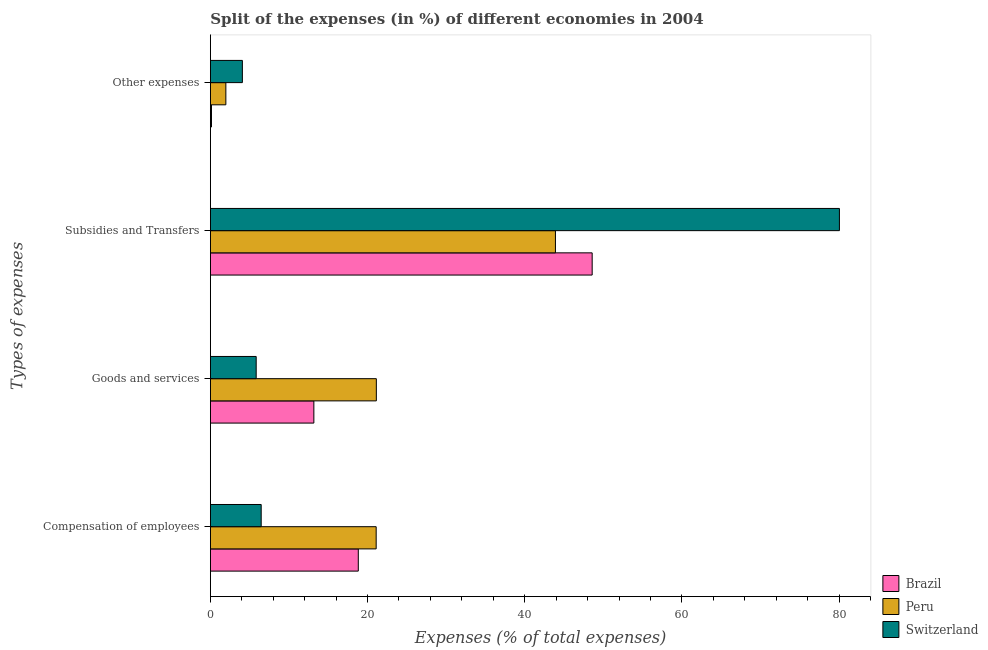How many different coloured bars are there?
Keep it short and to the point. 3. Are the number of bars on each tick of the Y-axis equal?
Give a very brief answer. Yes. How many bars are there on the 3rd tick from the top?
Ensure brevity in your answer.  3. How many bars are there on the 4th tick from the bottom?
Keep it short and to the point. 3. What is the label of the 4th group of bars from the top?
Provide a succinct answer. Compensation of employees. What is the percentage of amount spent on subsidies in Brazil?
Your response must be concise. 48.59. Across all countries, what is the maximum percentage of amount spent on subsidies?
Provide a short and direct response. 80.05. Across all countries, what is the minimum percentage of amount spent on goods and services?
Make the answer very short. 5.83. In which country was the percentage of amount spent on other expenses maximum?
Provide a succinct answer. Switzerland. In which country was the percentage of amount spent on compensation of employees minimum?
Provide a short and direct response. Switzerland. What is the total percentage of amount spent on goods and services in the graph?
Give a very brief answer. 40.11. What is the difference between the percentage of amount spent on other expenses in Peru and that in Switzerland?
Offer a very short reply. -2.1. What is the difference between the percentage of amount spent on compensation of employees in Brazil and the percentage of amount spent on goods and services in Switzerland?
Keep it short and to the point. 13. What is the average percentage of amount spent on subsidies per country?
Offer a terse response. 57.52. What is the difference between the percentage of amount spent on subsidies and percentage of amount spent on other expenses in Peru?
Provide a short and direct response. 41.94. In how many countries, is the percentage of amount spent on compensation of employees greater than 40 %?
Give a very brief answer. 0. What is the ratio of the percentage of amount spent on compensation of employees in Switzerland to that in Brazil?
Provide a succinct answer. 0.34. Is the percentage of amount spent on compensation of employees in Switzerland less than that in Peru?
Your response must be concise. Yes. Is the difference between the percentage of amount spent on other expenses in Brazil and Switzerland greater than the difference between the percentage of amount spent on compensation of employees in Brazil and Switzerland?
Give a very brief answer. No. What is the difference between the highest and the second highest percentage of amount spent on goods and services?
Make the answer very short. 7.95. What is the difference between the highest and the lowest percentage of amount spent on goods and services?
Ensure brevity in your answer.  15.29. In how many countries, is the percentage of amount spent on goods and services greater than the average percentage of amount spent on goods and services taken over all countries?
Provide a succinct answer. 1. What does the 3rd bar from the bottom in Subsidies and Transfers represents?
Offer a very short reply. Switzerland. How many bars are there?
Make the answer very short. 12. How many countries are there in the graph?
Your answer should be compact. 3. Where does the legend appear in the graph?
Provide a short and direct response. Bottom right. What is the title of the graph?
Offer a very short reply. Split of the expenses (in %) of different economies in 2004. What is the label or title of the X-axis?
Make the answer very short. Expenses (% of total expenses). What is the label or title of the Y-axis?
Give a very brief answer. Types of expenses. What is the Expenses (% of total expenses) in Brazil in Compensation of employees?
Keep it short and to the point. 18.82. What is the Expenses (% of total expenses) in Peru in Compensation of employees?
Provide a short and direct response. 21.1. What is the Expenses (% of total expenses) in Switzerland in Compensation of employees?
Provide a succinct answer. 6.47. What is the Expenses (% of total expenses) in Brazil in Goods and services?
Give a very brief answer. 13.17. What is the Expenses (% of total expenses) of Peru in Goods and services?
Offer a terse response. 21.12. What is the Expenses (% of total expenses) in Switzerland in Goods and services?
Give a very brief answer. 5.83. What is the Expenses (% of total expenses) of Brazil in Subsidies and Transfers?
Make the answer very short. 48.59. What is the Expenses (% of total expenses) in Peru in Subsidies and Transfers?
Your response must be concise. 43.91. What is the Expenses (% of total expenses) in Switzerland in Subsidies and Transfers?
Give a very brief answer. 80.05. What is the Expenses (% of total expenses) in Brazil in Other expenses?
Your response must be concise. 0.14. What is the Expenses (% of total expenses) in Peru in Other expenses?
Provide a short and direct response. 1.97. What is the Expenses (% of total expenses) in Switzerland in Other expenses?
Offer a very short reply. 4.07. Across all Types of expenses, what is the maximum Expenses (% of total expenses) in Brazil?
Your response must be concise. 48.59. Across all Types of expenses, what is the maximum Expenses (% of total expenses) of Peru?
Keep it short and to the point. 43.91. Across all Types of expenses, what is the maximum Expenses (% of total expenses) in Switzerland?
Your response must be concise. 80.05. Across all Types of expenses, what is the minimum Expenses (% of total expenses) in Brazil?
Offer a very short reply. 0.14. Across all Types of expenses, what is the minimum Expenses (% of total expenses) of Peru?
Provide a short and direct response. 1.97. Across all Types of expenses, what is the minimum Expenses (% of total expenses) of Switzerland?
Your answer should be compact. 4.07. What is the total Expenses (% of total expenses) of Brazil in the graph?
Offer a very short reply. 80.72. What is the total Expenses (% of total expenses) in Peru in the graph?
Offer a very short reply. 88.1. What is the total Expenses (% of total expenses) in Switzerland in the graph?
Keep it short and to the point. 96.41. What is the difference between the Expenses (% of total expenses) in Brazil in Compensation of employees and that in Goods and services?
Offer a very short reply. 5.66. What is the difference between the Expenses (% of total expenses) of Peru in Compensation of employees and that in Goods and services?
Provide a short and direct response. -0.02. What is the difference between the Expenses (% of total expenses) in Switzerland in Compensation of employees and that in Goods and services?
Provide a succinct answer. 0.64. What is the difference between the Expenses (% of total expenses) of Brazil in Compensation of employees and that in Subsidies and Transfers?
Provide a short and direct response. -29.76. What is the difference between the Expenses (% of total expenses) in Peru in Compensation of employees and that in Subsidies and Transfers?
Provide a succinct answer. -22.81. What is the difference between the Expenses (% of total expenses) in Switzerland in Compensation of employees and that in Subsidies and Transfers?
Provide a short and direct response. -73.58. What is the difference between the Expenses (% of total expenses) of Brazil in Compensation of employees and that in Other expenses?
Offer a terse response. 18.68. What is the difference between the Expenses (% of total expenses) of Peru in Compensation of employees and that in Other expenses?
Offer a very short reply. 19.13. What is the difference between the Expenses (% of total expenses) of Switzerland in Compensation of employees and that in Other expenses?
Your answer should be very brief. 2.39. What is the difference between the Expenses (% of total expenses) of Brazil in Goods and services and that in Subsidies and Transfers?
Your response must be concise. -35.42. What is the difference between the Expenses (% of total expenses) in Peru in Goods and services and that in Subsidies and Transfers?
Your answer should be compact. -22.79. What is the difference between the Expenses (% of total expenses) of Switzerland in Goods and services and that in Subsidies and Transfers?
Give a very brief answer. -74.22. What is the difference between the Expenses (% of total expenses) in Brazil in Goods and services and that in Other expenses?
Provide a succinct answer. 13.03. What is the difference between the Expenses (% of total expenses) of Peru in Goods and services and that in Other expenses?
Keep it short and to the point. 19.15. What is the difference between the Expenses (% of total expenses) of Switzerland in Goods and services and that in Other expenses?
Provide a succinct answer. 1.76. What is the difference between the Expenses (% of total expenses) in Brazil in Subsidies and Transfers and that in Other expenses?
Your answer should be very brief. 48.45. What is the difference between the Expenses (% of total expenses) in Peru in Subsidies and Transfers and that in Other expenses?
Provide a short and direct response. 41.94. What is the difference between the Expenses (% of total expenses) of Switzerland in Subsidies and Transfers and that in Other expenses?
Provide a short and direct response. 75.98. What is the difference between the Expenses (% of total expenses) in Brazil in Compensation of employees and the Expenses (% of total expenses) in Peru in Goods and services?
Keep it short and to the point. -2.3. What is the difference between the Expenses (% of total expenses) of Brazil in Compensation of employees and the Expenses (% of total expenses) of Switzerland in Goods and services?
Provide a succinct answer. 13. What is the difference between the Expenses (% of total expenses) in Peru in Compensation of employees and the Expenses (% of total expenses) in Switzerland in Goods and services?
Offer a very short reply. 15.27. What is the difference between the Expenses (% of total expenses) in Brazil in Compensation of employees and the Expenses (% of total expenses) in Peru in Subsidies and Transfers?
Give a very brief answer. -25.09. What is the difference between the Expenses (% of total expenses) of Brazil in Compensation of employees and the Expenses (% of total expenses) of Switzerland in Subsidies and Transfers?
Your answer should be very brief. -61.23. What is the difference between the Expenses (% of total expenses) of Peru in Compensation of employees and the Expenses (% of total expenses) of Switzerland in Subsidies and Transfers?
Offer a terse response. -58.95. What is the difference between the Expenses (% of total expenses) in Brazil in Compensation of employees and the Expenses (% of total expenses) in Peru in Other expenses?
Give a very brief answer. 16.85. What is the difference between the Expenses (% of total expenses) in Brazil in Compensation of employees and the Expenses (% of total expenses) in Switzerland in Other expenses?
Offer a terse response. 14.75. What is the difference between the Expenses (% of total expenses) in Peru in Compensation of employees and the Expenses (% of total expenses) in Switzerland in Other expenses?
Offer a very short reply. 17.03. What is the difference between the Expenses (% of total expenses) of Brazil in Goods and services and the Expenses (% of total expenses) of Peru in Subsidies and Transfers?
Your answer should be very brief. -30.74. What is the difference between the Expenses (% of total expenses) of Brazil in Goods and services and the Expenses (% of total expenses) of Switzerland in Subsidies and Transfers?
Offer a very short reply. -66.88. What is the difference between the Expenses (% of total expenses) in Peru in Goods and services and the Expenses (% of total expenses) in Switzerland in Subsidies and Transfers?
Keep it short and to the point. -58.93. What is the difference between the Expenses (% of total expenses) of Brazil in Goods and services and the Expenses (% of total expenses) of Peru in Other expenses?
Give a very brief answer. 11.2. What is the difference between the Expenses (% of total expenses) of Brazil in Goods and services and the Expenses (% of total expenses) of Switzerland in Other expenses?
Provide a short and direct response. 9.1. What is the difference between the Expenses (% of total expenses) in Peru in Goods and services and the Expenses (% of total expenses) in Switzerland in Other expenses?
Offer a terse response. 17.05. What is the difference between the Expenses (% of total expenses) in Brazil in Subsidies and Transfers and the Expenses (% of total expenses) in Peru in Other expenses?
Give a very brief answer. 46.62. What is the difference between the Expenses (% of total expenses) in Brazil in Subsidies and Transfers and the Expenses (% of total expenses) in Switzerland in Other expenses?
Offer a very short reply. 44.52. What is the difference between the Expenses (% of total expenses) of Peru in Subsidies and Transfers and the Expenses (% of total expenses) of Switzerland in Other expenses?
Keep it short and to the point. 39.84. What is the average Expenses (% of total expenses) in Brazil per Types of expenses?
Ensure brevity in your answer.  20.18. What is the average Expenses (% of total expenses) of Peru per Types of expenses?
Provide a short and direct response. 22.02. What is the average Expenses (% of total expenses) in Switzerland per Types of expenses?
Offer a very short reply. 24.1. What is the difference between the Expenses (% of total expenses) of Brazil and Expenses (% of total expenses) of Peru in Compensation of employees?
Give a very brief answer. -2.27. What is the difference between the Expenses (% of total expenses) in Brazil and Expenses (% of total expenses) in Switzerland in Compensation of employees?
Offer a very short reply. 12.36. What is the difference between the Expenses (% of total expenses) in Peru and Expenses (% of total expenses) in Switzerland in Compensation of employees?
Your response must be concise. 14.63. What is the difference between the Expenses (% of total expenses) in Brazil and Expenses (% of total expenses) in Peru in Goods and services?
Your response must be concise. -7.95. What is the difference between the Expenses (% of total expenses) in Brazil and Expenses (% of total expenses) in Switzerland in Goods and services?
Your answer should be compact. 7.34. What is the difference between the Expenses (% of total expenses) of Peru and Expenses (% of total expenses) of Switzerland in Goods and services?
Offer a terse response. 15.29. What is the difference between the Expenses (% of total expenses) of Brazil and Expenses (% of total expenses) of Peru in Subsidies and Transfers?
Make the answer very short. 4.67. What is the difference between the Expenses (% of total expenses) in Brazil and Expenses (% of total expenses) in Switzerland in Subsidies and Transfers?
Your response must be concise. -31.46. What is the difference between the Expenses (% of total expenses) in Peru and Expenses (% of total expenses) in Switzerland in Subsidies and Transfers?
Offer a terse response. -36.14. What is the difference between the Expenses (% of total expenses) of Brazil and Expenses (% of total expenses) of Peru in Other expenses?
Offer a very short reply. -1.83. What is the difference between the Expenses (% of total expenses) in Brazil and Expenses (% of total expenses) in Switzerland in Other expenses?
Your response must be concise. -3.93. What is the difference between the Expenses (% of total expenses) of Peru and Expenses (% of total expenses) of Switzerland in Other expenses?
Keep it short and to the point. -2.1. What is the ratio of the Expenses (% of total expenses) in Brazil in Compensation of employees to that in Goods and services?
Your answer should be compact. 1.43. What is the ratio of the Expenses (% of total expenses) of Peru in Compensation of employees to that in Goods and services?
Provide a succinct answer. 1. What is the ratio of the Expenses (% of total expenses) of Switzerland in Compensation of employees to that in Goods and services?
Your answer should be compact. 1.11. What is the ratio of the Expenses (% of total expenses) in Brazil in Compensation of employees to that in Subsidies and Transfers?
Offer a very short reply. 0.39. What is the ratio of the Expenses (% of total expenses) of Peru in Compensation of employees to that in Subsidies and Transfers?
Keep it short and to the point. 0.48. What is the ratio of the Expenses (% of total expenses) of Switzerland in Compensation of employees to that in Subsidies and Transfers?
Provide a short and direct response. 0.08. What is the ratio of the Expenses (% of total expenses) of Brazil in Compensation of employees to that in Other expenses?
Offer a very short reply. 134.48. What is the ratio of the Expenses (% of total expenses) of Peru in Compensation of employees to that in Other expenses?
Offer a terse response. 10.72. What is the ratio of the Expenses (% of total expenses) of Switzerland in Compensation of employees to that in Other expenses?
Keep it short and to the point. 1.59. What is the ratio of the Expenses (% of total expenses) of Brazil in Goods and services to that in Subsidies and Transfers?
Offer a very short reply. 0.27. What is the ratio of the Expenses (% of total expenses) of Peru in Goods and services to that in Subsidies and Transfers?
Keep it short and to the point. 0.48. What is the ratio of the Expenses (% of total expenses) in Switzerland in Goods and services to that in Subsidies and Transfers?
Keep it short and to the point. 0.07. What is the ratio of the Expenses (% of total expenses) of Brazil in Goods and services to that in Other expenses?
Your answer should be compact. 94.07. What is the ratio of the Expenses (% of total expenses) in Peru in Goods and services to that in Other expenses?
Make the answer very short. 10.73. What is the ratio of the Expenses (% of total expenses) of Switzerland in Goods and services to that in Other expenses?
Give a very brief answer. 1.43. What is the ratio of the Expenses (% of total expenses) of Brazil in Subsidies and Transfers to that in Other expenses?
Provide a succinct answer. 347.12. What is the ratio of the Expenses (% of total expenses) of Peru in Subsidies and Transfers to that in Other expenses?
Provide a succinct answer. 22.3. What is the ratio of the Expenses (% of total expenses) in Switzerland in Subsidies and Transfers to that in Other expenses?
Make the answer very short. 19.66. What is the difference between the highest and the second highest Expenses (% of total expenses) in Brazil?
Keep it short and to the point. 29.76. What is the difference between the highest and the second highest Expenses (% of total expenses) of Peru?
Give a very brief answer. 22.79. What is the difference between the highest and the second highest Expenses (% of total expenses) of Switzerland?
Offer a terse response. 73.58. What is the difference between the highest and the lowest Expenses (% of total expenses) in Brazil?
Your answer should be very brief. 48.45. What is the difference between the highest and the lowest Expenses (% of total expenses) in Peru?
Make the answer very short. 41.94. What is the difference between the highest and the lowest Expenses (% of total expenses) of Switzerland?
Give a very brief answer. 75.98. 